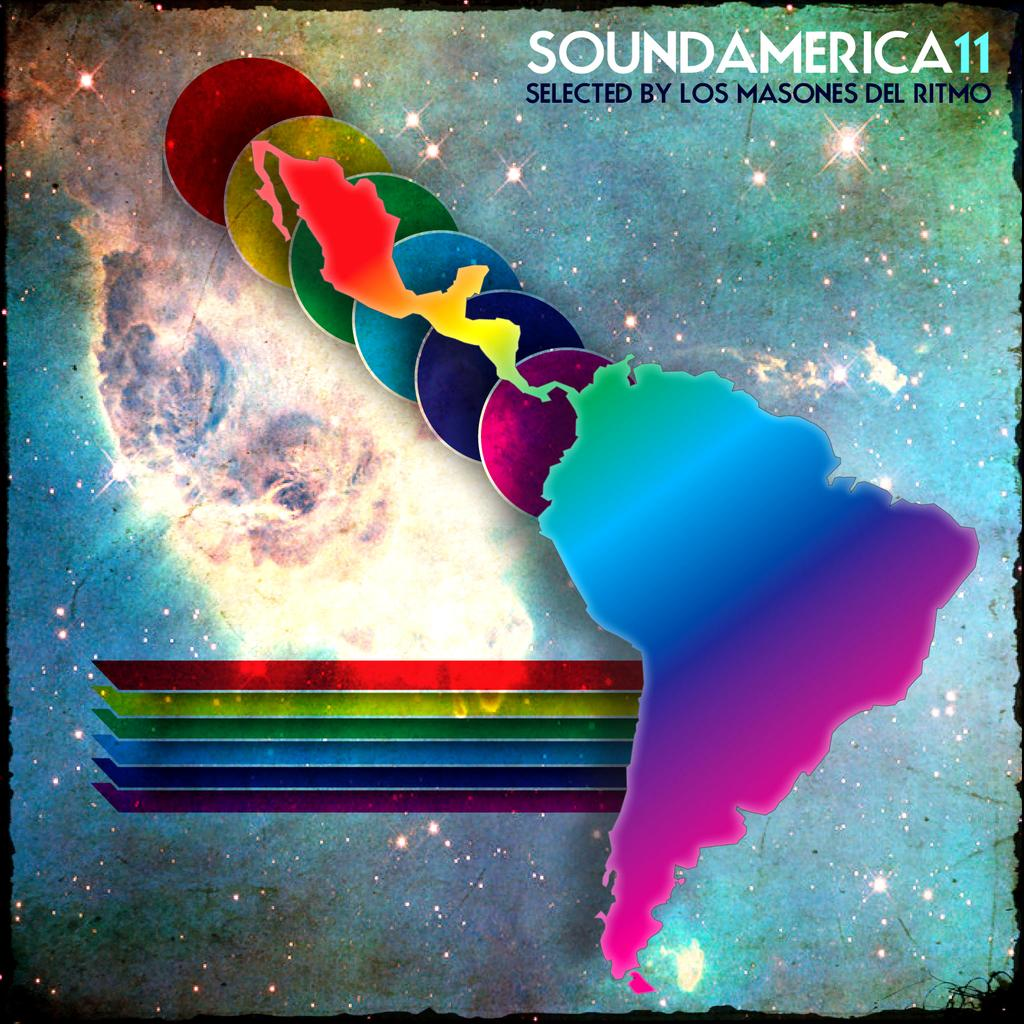Provide a one-sentence caption for the provided image. An album cover for the album SoundAmerica 11. 